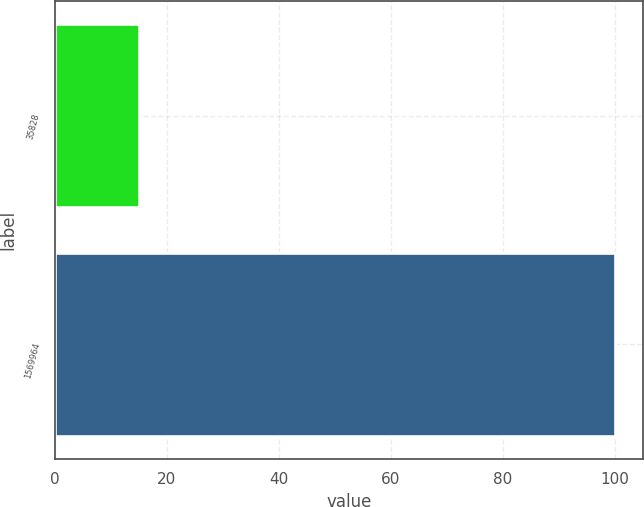<chart> <loc_0><loc_0><loc_500><loc_500><bar_chart><fcel>35828<fcel>1569964<nl><fcel>15<fcel>100<nl></chart> 